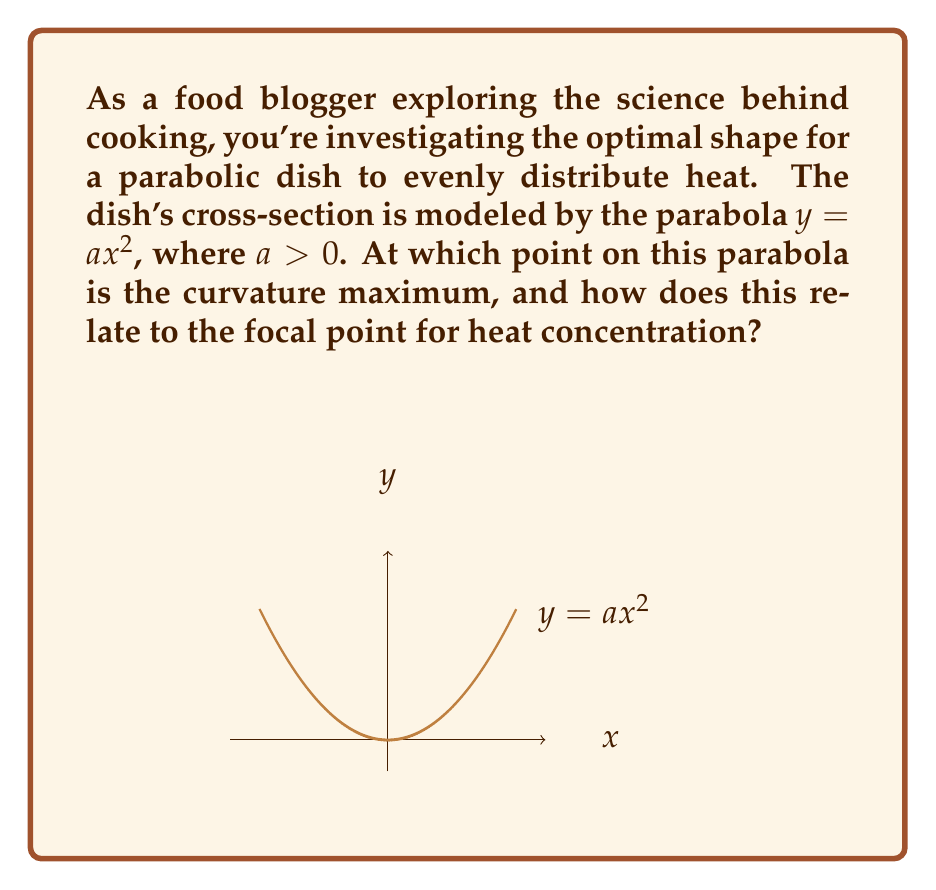Teach me how to tackle this problem. Let's approach this step-by-step:

1) The curvature $\kappa$ of a curve $y = f(x)$ is given by:

   $$\kappa = \frac{|f''(x)|}{(1 + (f'(x))^2)^{3/2}}$$

2) For our parabola $y = ax^2$:
   $f'(x) = 2ax$
   $f''(x) = 2a$

3) Substituting into the curvature formula:

   $$\kappa = \frac{|2a|}{(1 + (2ax)^2)^{3/2}}$$

4) To find the maximum curvature, we need to find where $\frac{d\kappa}{dx} = 0$:

   $$\frac{d\kappa}{dx} = -\frac{12a^3x}{(1 + 4a^2x^2)^{5/2}} = 0$$

5) This is zero when $x = 0$, which corresponds to the vertex of the parabola.

6) The maximum curvature occurs at $(0, 0)$ and its value is:

   $$\kappa_{max} = 2a$$

7) For a parabolic reflector, the focal point is located at $(0, \frac{1}{4a})$.

8) The relationship between the maximum curvature point and the focal point is crucial for heat distribution. The vertex (0,0) is where the curvature is maximum, and it's also the point closest to the focal point. This ensures that heat is concentrated most intensely at the focal point, which is ideal for cooking applications.
Answer: Maximum curvature at $(0,0)$; $\kappa_{max} = 2a$; focal point at $(0, \frac{1}{4a})$. 